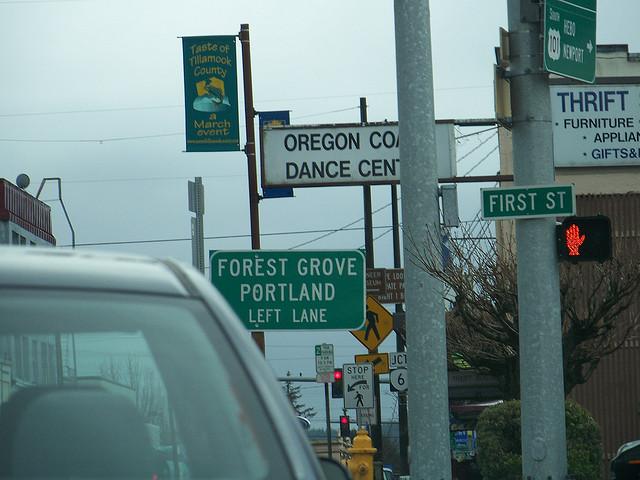Is there a dance studio?
Short answer required. Yes. What lane leads to Forest Grove Portland?
Write a very short answer. Left. What state is the photo from?
Answer briefly. Oregon. 